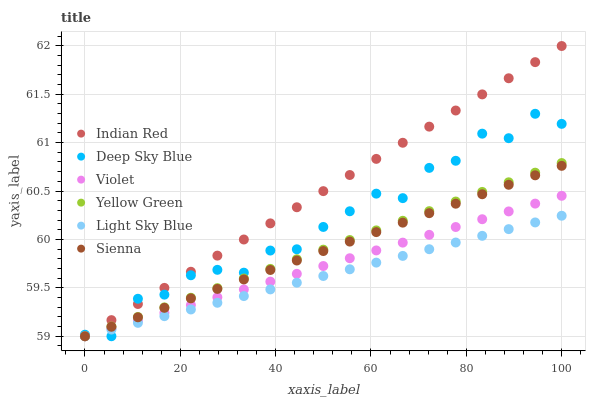Does Light Sky Blue have the minimum area under the curve?
Answer yes or no. Yes. Does Indian Red have the maximum area under the curve?
Answer yes or no. Yes. Does Sienna have the minimum area under the curve?
Answer yes or no. No. Does Sienna have the maximum area under the curve?
Answer yes or no. No. Is Light Sky Blue the smoothest?
Answer yes or no. Yes. Is Deep Sky Blue the roughest?
Answer yes or no. Yes. Is Sienna the smoothest?
Answer yes or no. No. Is Sienna the roughest?
Answer yes or no. No. Does Yellow Green have the lowest value?
Answer yes or no. Yes. Does Indian Red have the highest value?
Answer yes or no. Yes. Does Sienna have the highest value?
Answer yes or no. No. Does Deep Sky Blue intersect Sienna?
Answer yes or no. Yes. Is Deep Sky Blue less than Sienna?
Answer yes or no. No. Is Deep Sky Blue greater than Sienna?
Answer yes or no. No. 